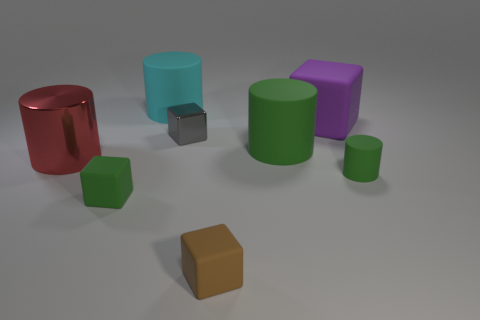How many other things are the same shape as the tiny brown object?
Your response must be concise. 3. What color is the metallic cylinder that is the same size as the purple matte thing?
Ensure brevity in your answer.  Red. How many things are either gray cubes or green rubber balls?
Your answer should be very brief. 1. Are there any green rubber cylinders behind the large green thing?
Your answer should be compact. No. Is there a cyan cylinder that has the same material as the cyan thing?
Offer a very short reply. No. What size is the block that is the same color as the tiny cylinder?
Ensure brevity in your answer.  Small. What number of cubes are either cyan metallic things or small metal objects?
Provide a short and direct response. 1. Are there more tiny green matte things that are to the right of the red shiny cylinder than big purple rubber objects that are right of the large cube?
Make the answer very short. Yes. How many tiny rubber cubes have the same color as the big metal cylinder?
Make the answer very short. 0. The green block that is made of the same material as the big purple cube is what size?
Your response must be concise. Small. 